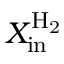<formula> <loc_0><loc_0><loc_500><loc_500>X _ { i n } ^ { H _ { 2 } }</formula> 